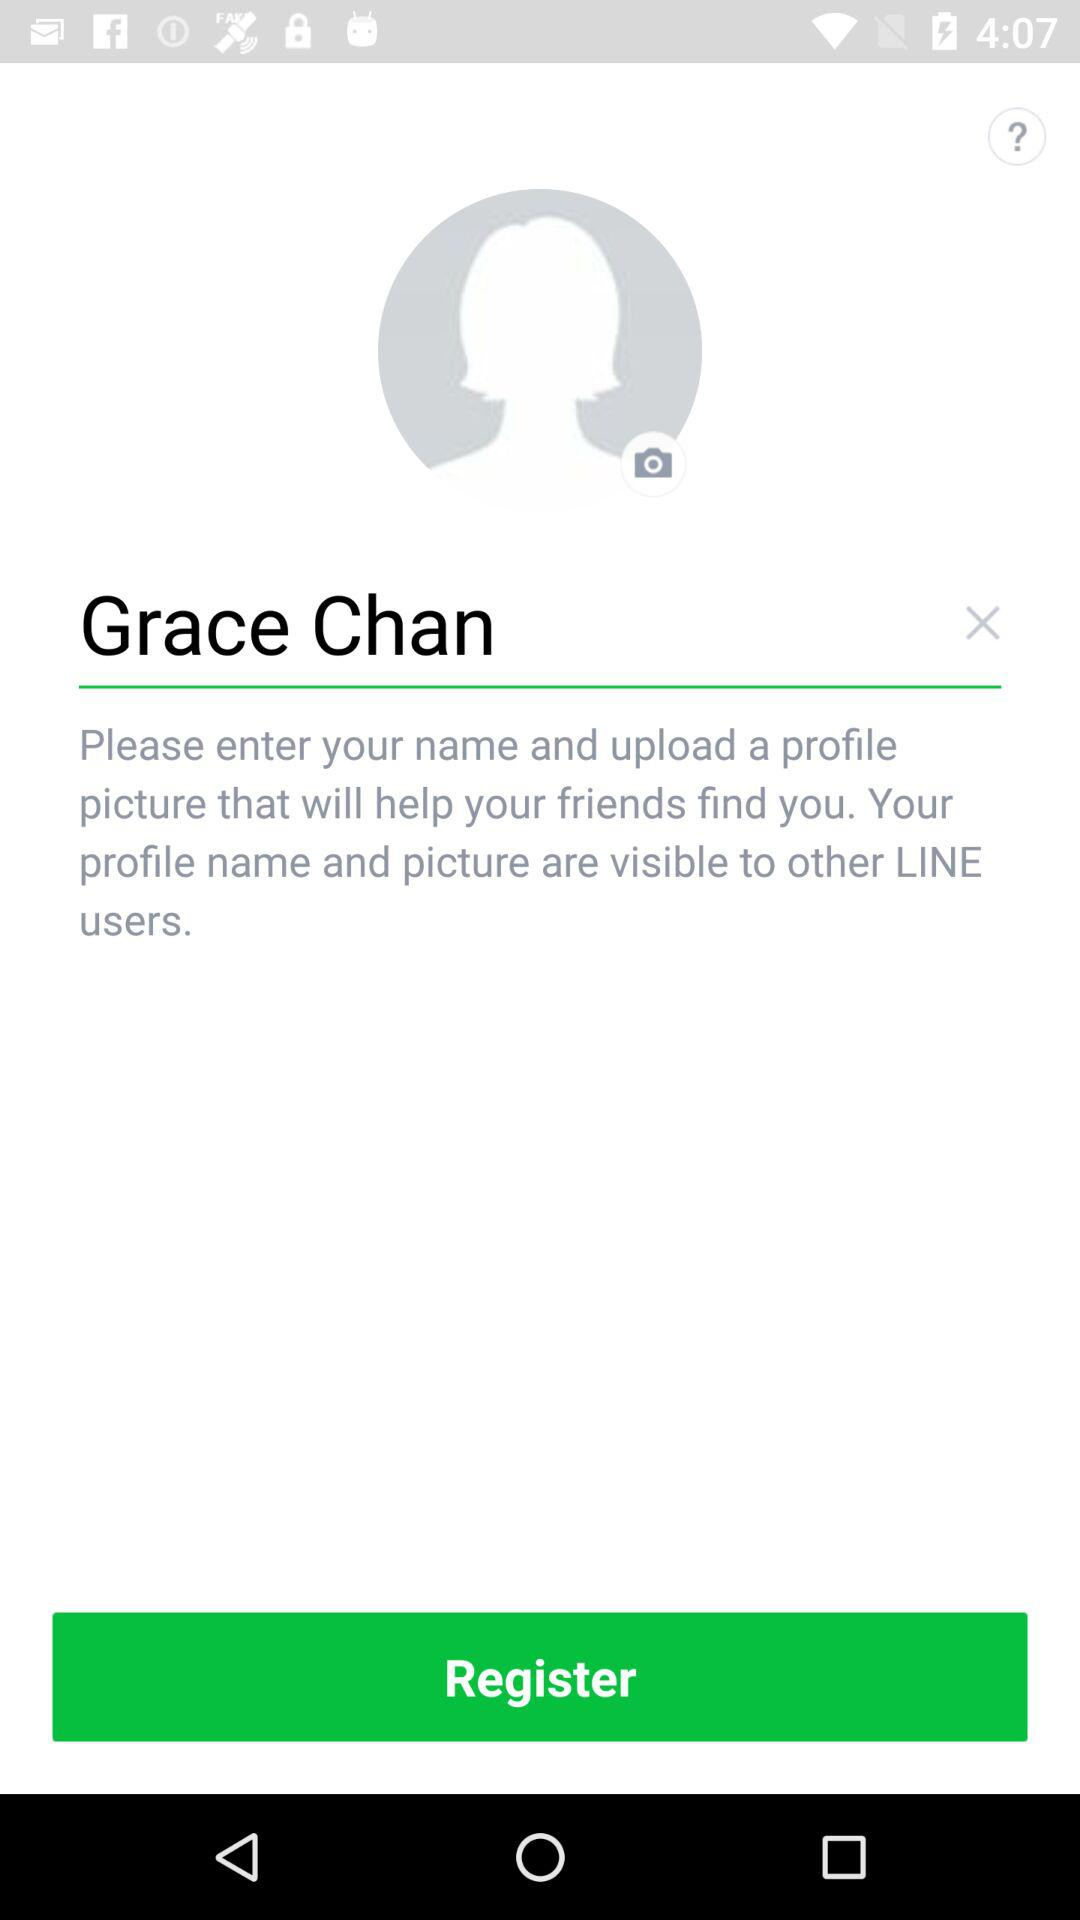What is the name? The name is Grace Chan. 